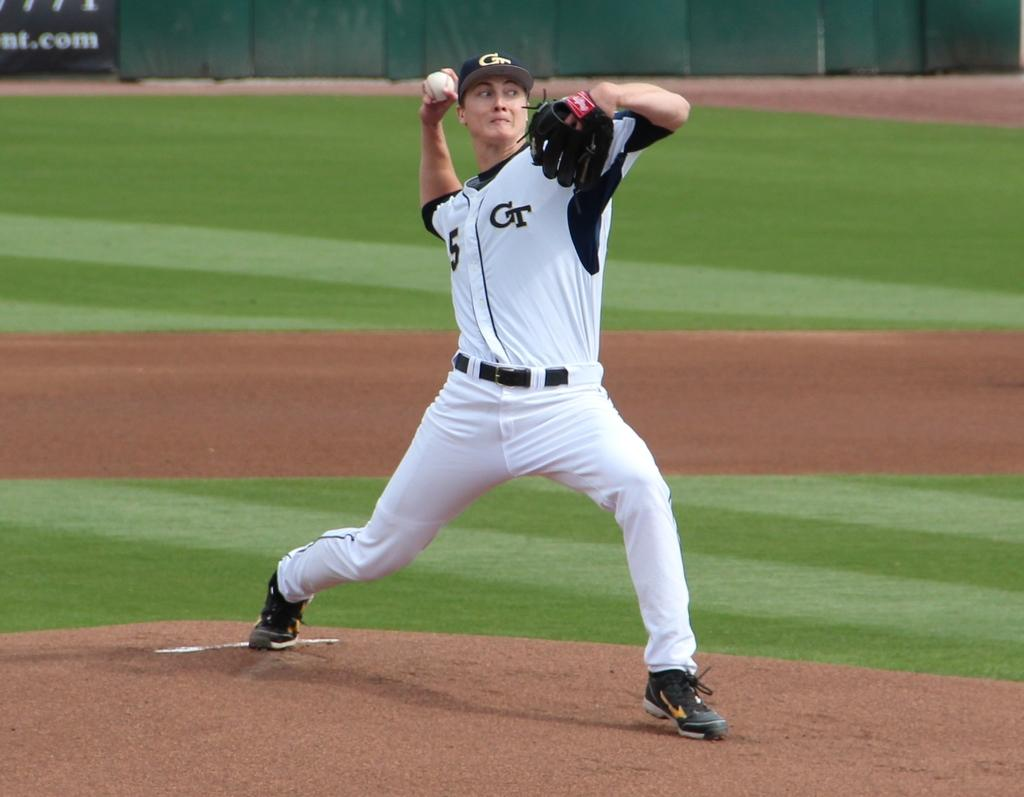<image>
Present a compact description of the photo's key features. A man throwing a baseball, the letters GT are on his shirt. 